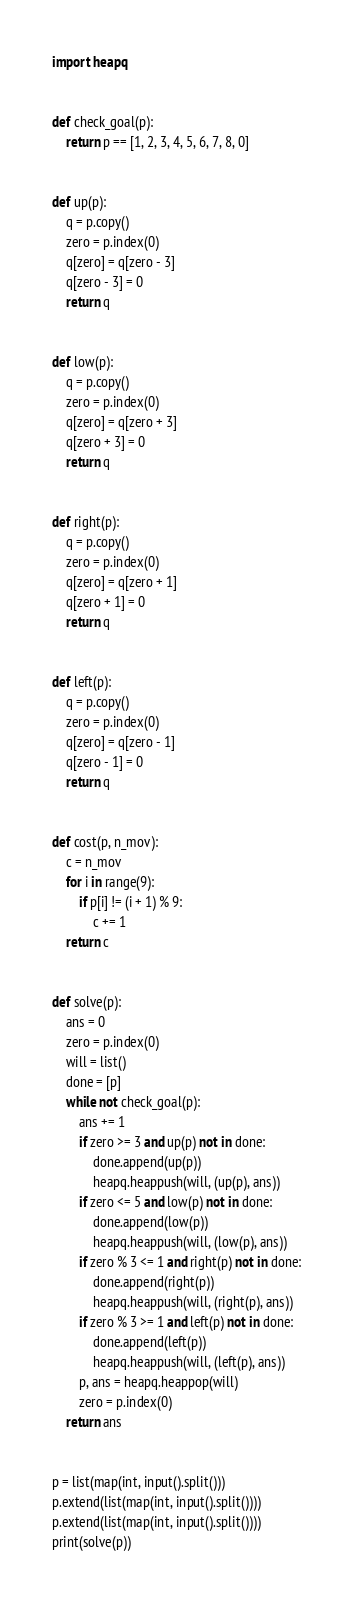<code> <loc_0><loc_0><loc_500><loc_500><_Python_>import heapq


def check_goal(p):
    return p == [1, 2, 3, 4, 5, 6, 7, 8, 0]


def up(p):
    q = p.copy()
    zero = p.index(0)
    q[zero] = q[zero - 3]
    q[zero - 3] = 0
    return q


def low(p):
    q = p.copy()
    zero = p.index(0)
    q[zero] = q[zero + 3]
    q[zero + 3] = 0
    return q


def right(p):
    q = p.copy()
    zero = p.index(0)
    q[zero] = q[zero + 1]
    q[zero + 1] = 0
    return q


def left(p):
    q = p.copy()
    zero = p.index(0)
    q[zero] = q[zero - 1]
    q[zero - 1] = 0
    return q


def cost(p, n_mov):
    c = n_mov
    for i in range(9):
        if p[i] != (i + 1) % 9:
            c += 1
    return c


def solve(p):
    ans = 0
    zero = p.index(0)
    will = list()
    done = [p]
    while not check_goal(p):
        ans += 1
        if zero >= 3 and up(p) not in done:
            done.append(up(p))
            heapq.heappush(will, (up(p), ans))
        if zero <= 5 and low(p) not in done:
            done.append(low(p))
            heapq.heappush(will, (low(p), ans))
        if zero % 3 <= 1 and right(p) not in done:
            done.append(right(p))
            heapq.heappush(will, (right(p), ans))
        if zero % 3 >= 1 and left(p) not in done:
            done.append(left(p))
            heapq.heappush(will, (left(p), ans))
        p, ans = heapq.heappop(will)
        zero = p.index(0)
    return ans


p = list(map(int, input().split()))
p.extend(list(map(int, input().split())))
p.extend(list(map(int, input().split())))
print(solve(p))
</code> 